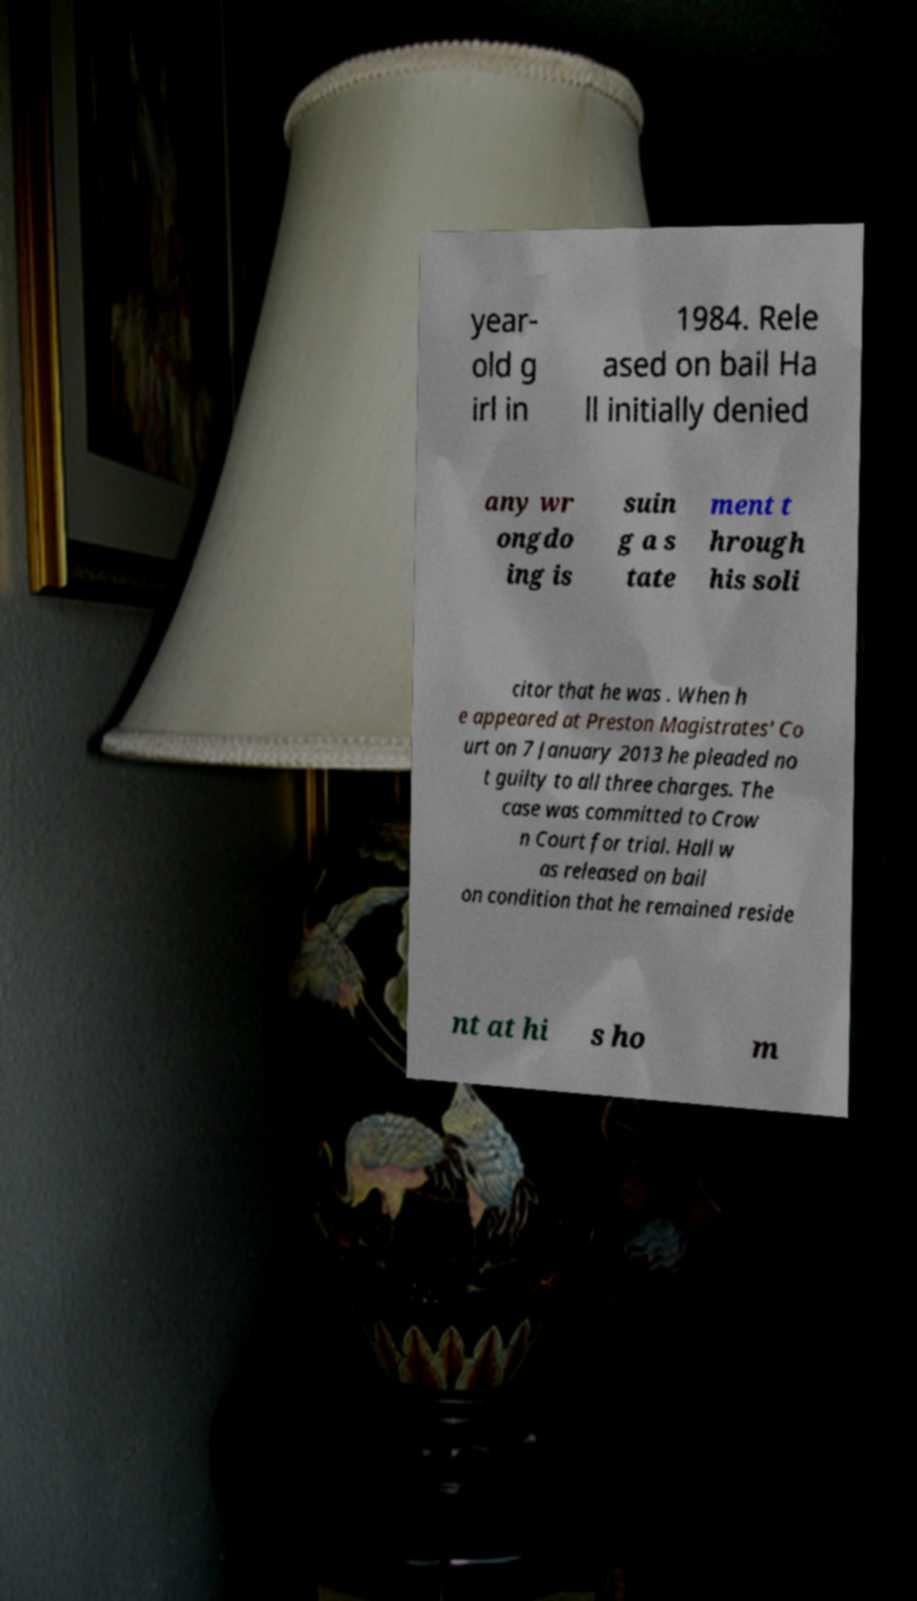What messages or text are displayed in this image? I need them in a readable, typed format. year- old g irl in 1984. Rele ased on bail Ha ll initially denied any wr ongdo ing is suin g a s tate ment t hrough his soli citor that he was . When h e appeared at Preston Magistrates' Co urt on 7 January 2013 he pleaded no t guilty to all three charges. The case was committed to Crow n Court for trial. Hall w as released on bail on condition that he remained reside nt at hi s ho m 